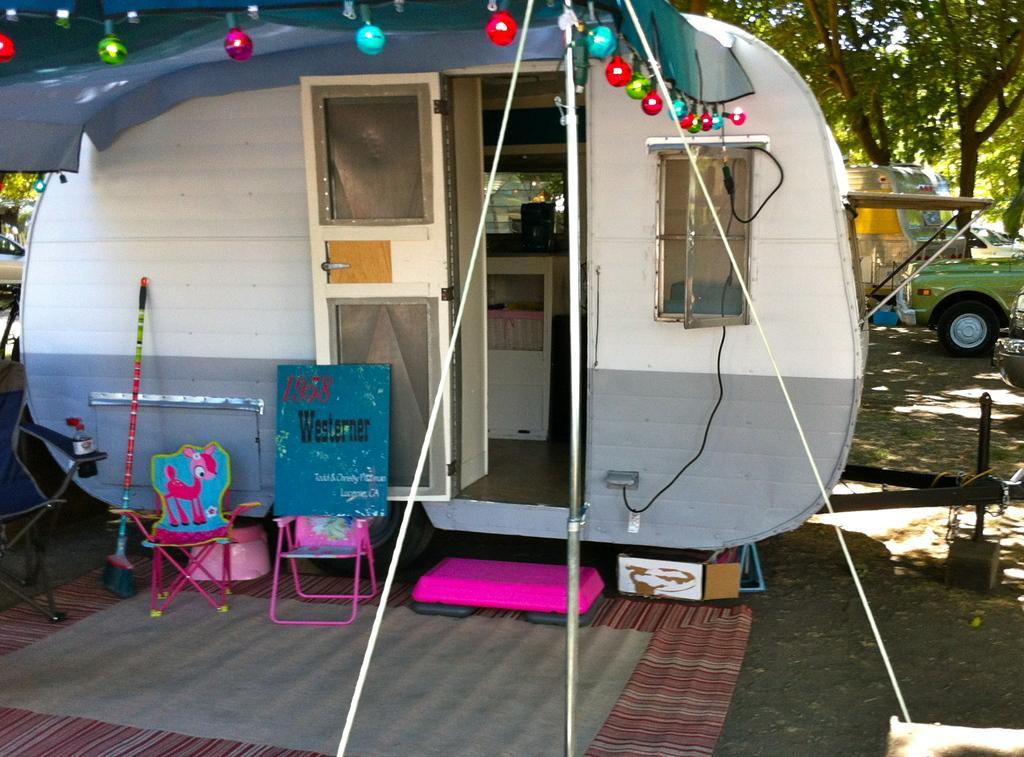How would you summarize this image in a sentence or two? This is a kind of a mobile home with a door and windows. I can see the kids chairs. This looks like a board. I think this is the broomstick. These are the colorful lights hanging to the cloth. This looks like a pole. Here is the mat. In the background, I can see a car and a truck. These are the trees. 